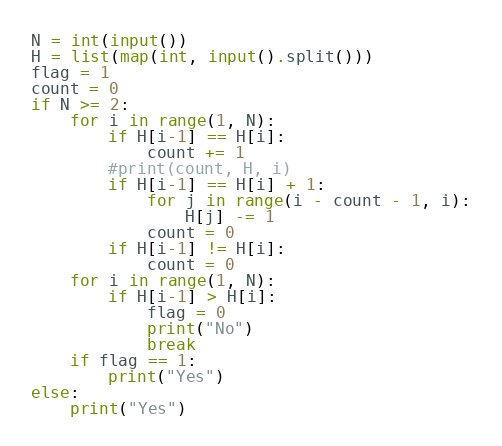<code> <loc_0><loc_0><loc_500><loc_500><_Python_>N = int(input())
H = list(map(int, input().split()))
flag = 1
count = 0
if N >= 2:
    for i in range(1, N):
        if H[i-1] == H[i]:
            count += 1
        #print(count, H, i)
        if H[i-1] == H[i] + 1:
            for j in range(i - count - 1, i):
                H[j] -= 1
            count = 0
        if H[i-1] != H[i]:
            count = 0
    for i in range(1, N):
        if H[i-1] > H[i]:
            flag = 0
            print("No")
            break
    if flag == 1:
        print("Yes")
else:
    print("Yes")
</code> 